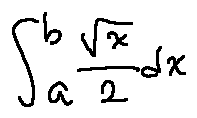Convert formula to latex. <formula><loc_0><loc_0><loc_500><loc_500>\int \lim i t s _ { a } ^ { b } \frac { \sqrt { x } } { 2 } d x</formula> 